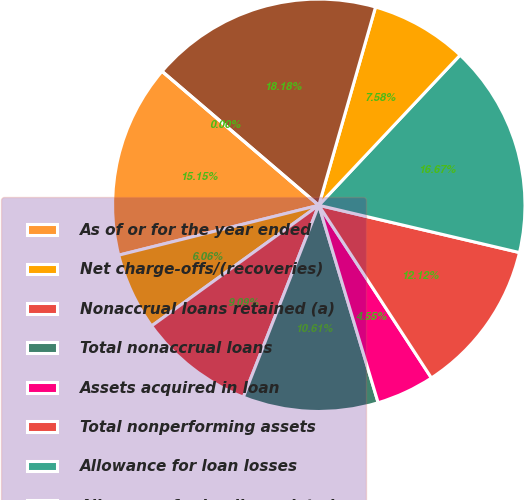Convert chart. <chart><loc_0><loc_0><loc_500><loc_500><pie_chart><fcel>As of or for the year ended<fcel>Net charge-offs/(recoveries)<fcel>Nonaccrual loans retained (a)<fcel>Total nonaccrual loans<fcel>Assets acquired in loan<fcel>Total nonperforming assets<fcel>Allowance for loan losses<fcel>Allowance for lending-related<fcel>Total allowance for credit<fcel>Net charge-off/(recovery) rate<nl><fcel>15.15%<fcel>6.06%<fcel>9.09%<fcel>10.61%<fcel>4.55%<fcel>12.12%<fcel>16.67%<fcel>7.58%<fcel>18.18%<fcel>0.0%<nl></chart> 